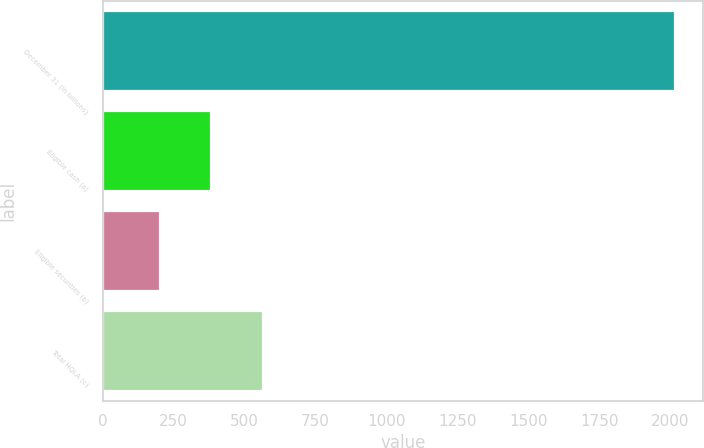Convert chart to OTSL. <chart><loc_0><loc_0><loc_500><loc_500><bar_chart><fcel>December 31 (in billions)<fcel>Eligible cash (a)<fcel>Eligible securities (b)<fcel>Total HQLA (c)<nl><fcel>2016<fcel>382.5<fcel>201<fcel>564<nl></chart> 